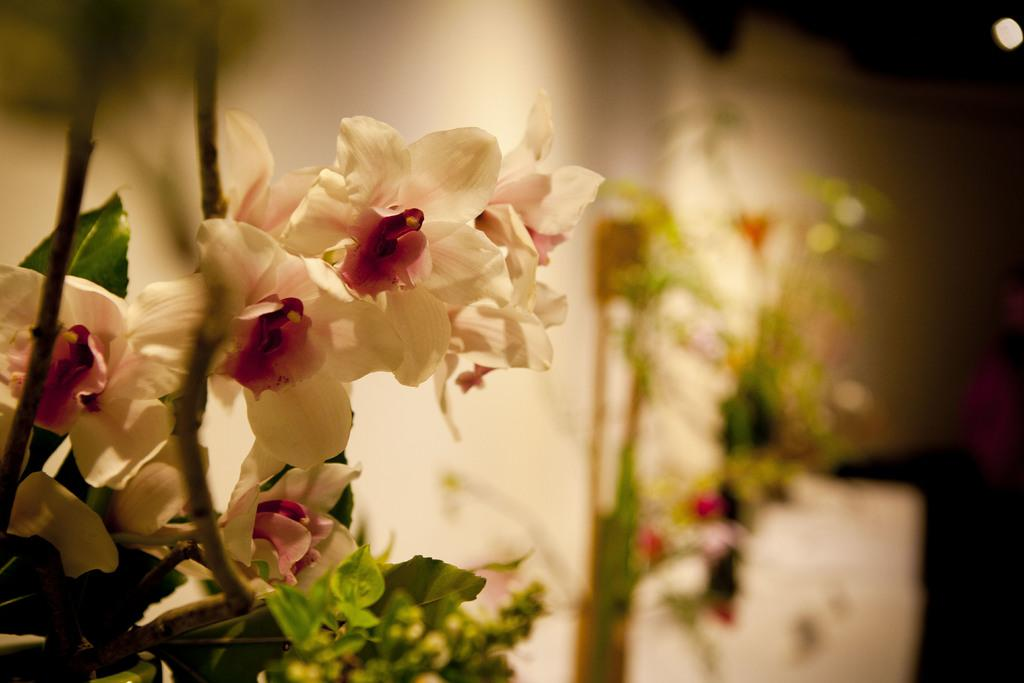What types of plants and flowers can be seen on the left side of the image? There are plants and flowers on the left side of the image, and they are in white and red colors. What is visible in the background of the image? There is a wall, plants, and other objects in the background of the image. What type of discussion is taking place between the cattle in the image? There are no cattle present in the image, so there cannot be a discussion between them. What is the nose of the plant in the image? There is no mention of a plant with a nose in the image; plants do not have noses. 